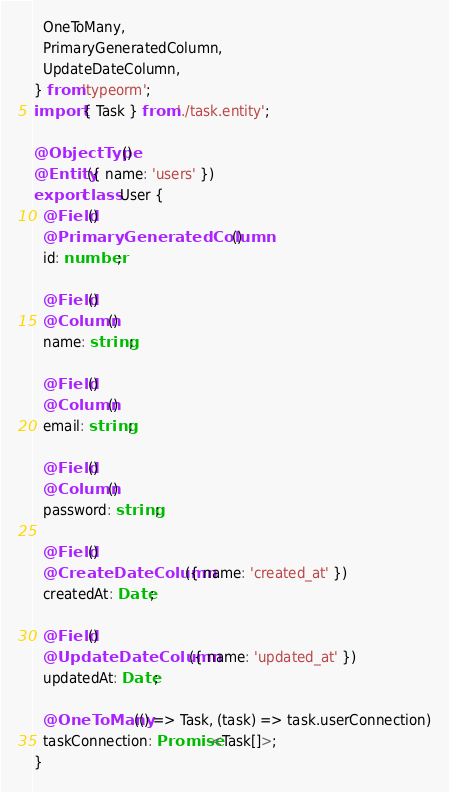<code> <loc_0><loc_0><loc_500><loc_500><_TypeScript_>  OneToMany,
  PrimaryGeneratedColumn,
  UpdateDateColumn,
} from 'typeorm';
import { Task } from './task.entity';

@ObjectType()
@Entity({ name: 'users' })
export class User {
  @Field()
  @PrimaryGeneratedColumn()
  id: number;

  @Field()
  @Column()
  name: string;

  @Field()
  @Column()
  email: string;

  @Field()
  @Column()
  password: string;

  @Field()
  @CreateDateColumn({ name: 'created_at' })
  createdAt: Date;

  @Field()
  @UpdateDateColumn({ name: 'updated_at' })
  updatedAt: Date;

  @OneToMany(() => Task, (task) => task.userConnection)
  taskConnection: Promise<Task[]>;
}
</code> 